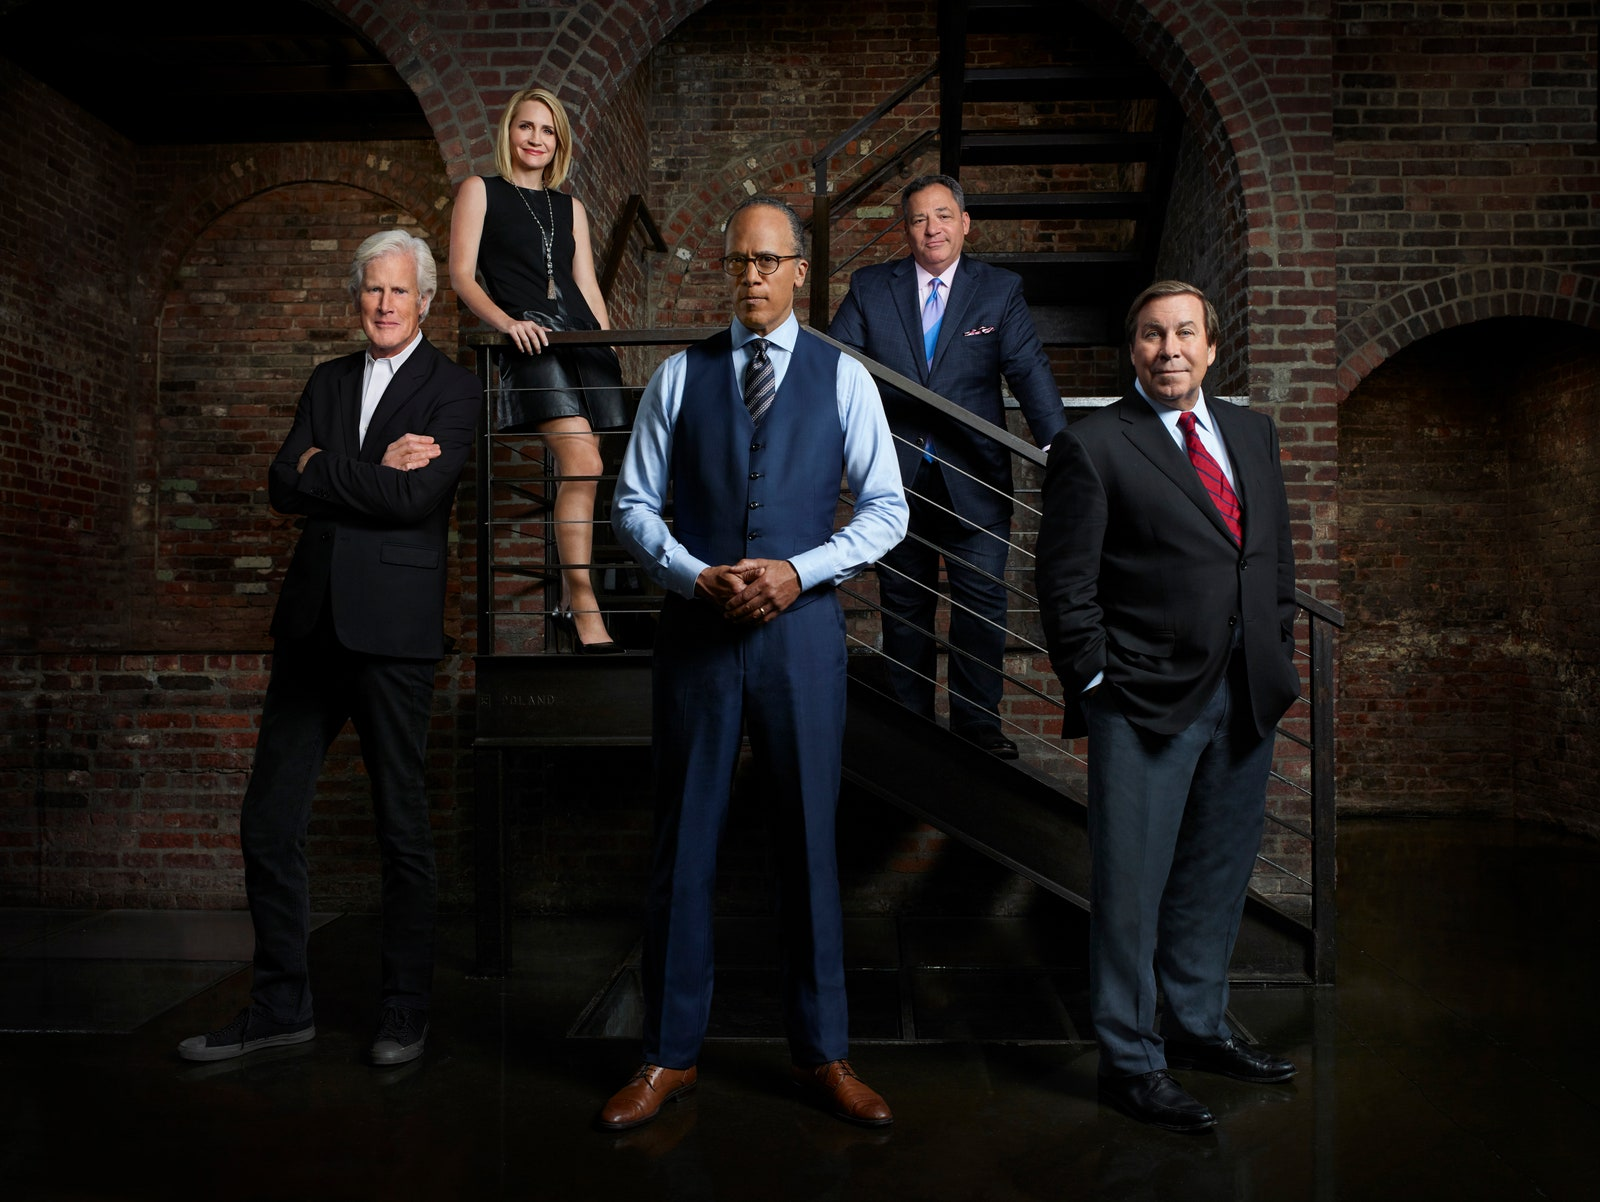Imagine this photo is set in a dystopian future. What roles would these individuals take on in this scenario? In a dystopian future, these individuals might be the leaders of a rebel faction fighting against an authoritarian regime. The man in the center could be the resolute and inspiring leader, rallying his people to rise against oppression. Surrounding him, his trusted advisors include a seasoned strategist (the man in a black suit), a resourceful technology expert (the woman), a skilled diplomat (the man in glasses), and a determined field commander (the man in a blue suit). Their goal is to undermine the regime, restore freedom, and build a new society from the ashes of the old. Describe a very short scenario that unfolds during their mission. During one daring mission, this team infiltrates a high-security facility to rescue imprisoned allies. Swift and meticulous, they navigate through a maze of surveillance systems and guards. The technology expert hacks into the mainframe to disable security, while the strategist guides their movements. The field commander leads the assault team, ensuring their safe passage while the diplomat negotiates their exit. Together, they achieve their objective, liberating their comrades and dealing a significant blow to the regime. 